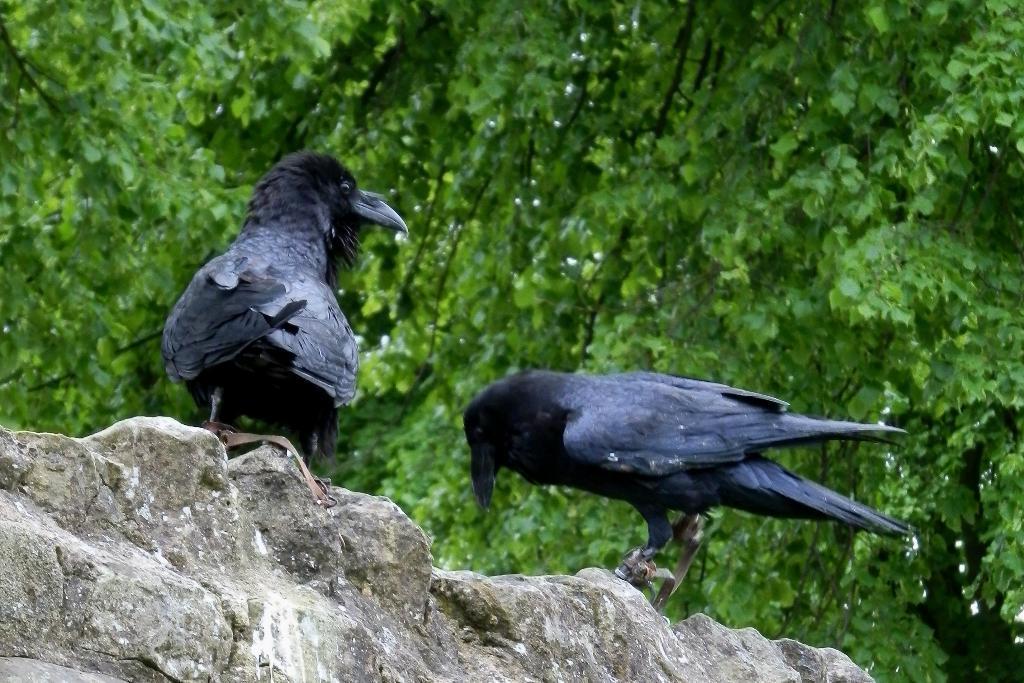Please provide a concise description of this image. In this picture we can see two birds on the stone wall. There are a few trees visible in the background. 